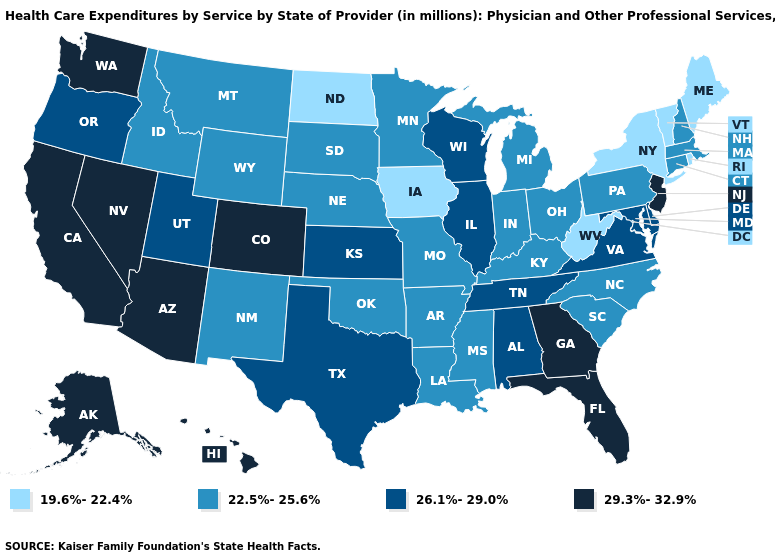What is the value of Nebraska?
Quick response, please. 22.5%-25.6%. What is the highest value in states that border Vermont?
Be succinct. 22.5%-25.6%. What is the lowest value in states that border Georgia?
Answer briefly. 22.5%-25.6%. What is the highest value in the South ?
Answer briefly. 29.3%-32.9%. Does Oregon have the same value as Utah?
Be succinct. Yes. Does Georgia have a higher value than Alabama?
Short answer required. Yes. Name the states that have a value in the range 22.5%-25.6%?
Give a very brief answer. Arkansas, Connecticut, Idaho, Indiana, Kentucky, Louisiana, Massachusetts, Michigan, Minnesota, Mississippi, Missouri, Montana, Nebraska, New Hampshire, New Mexico, North Carolina, Ohio, Oklahoma, Pennsylvania, South Carolina, South Dakota, Wyoming. What is the highest value in the MidWest ?
Be succinct. 26.1%-29.0%. Does Arizona have the highest value in the USA?
Write a very short answer. Yes. What is the lowest value in the Northeast?
Answer briefly. 19.6%-22.4%. Name the states that have a value in the range 26.1%-29.0%?
Quick response, please. Alabama, Delaware, Illinois, Kansas, Maryland, Oregon, Tennessee, Texas, Utah, Virginia, Wisconsin. Which states have the lowest value in the USA?
Answer briefly. Iowa, Maine, New York, North Dakota, Rhode Island, Vermont, West Virginia. Does Hawaii have the highest value in the USA?
Short answer required. Yes. Which states have the lowest value in the MidWest?
Quick response, please. Iowa, North Dakota. 